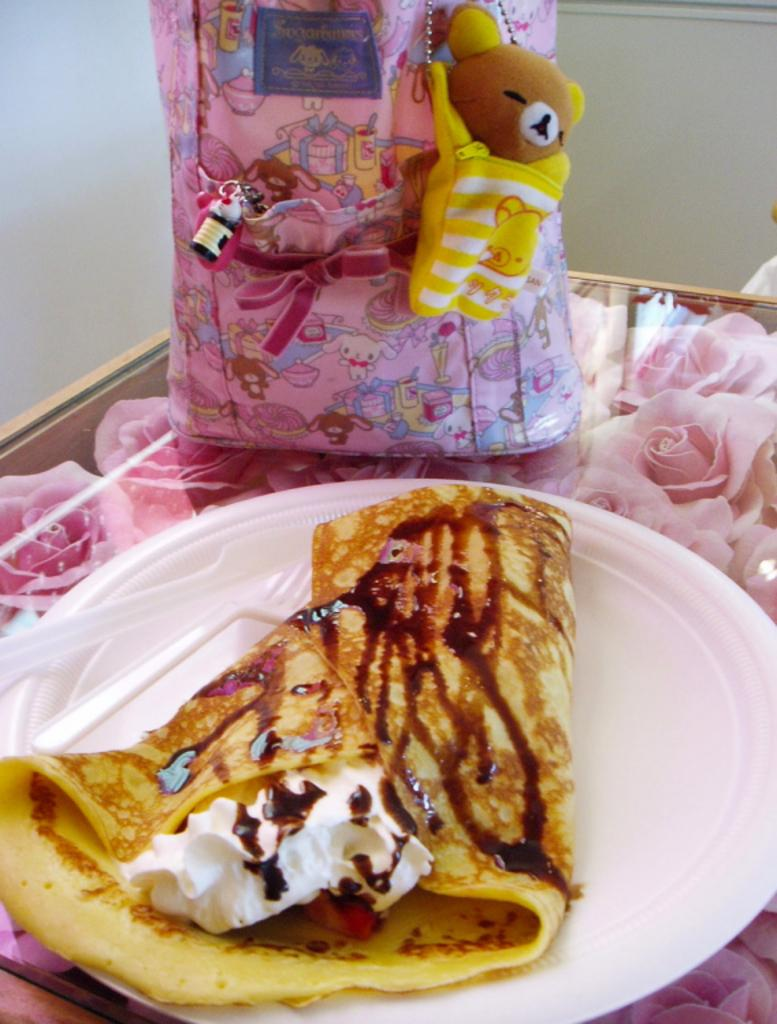What is the main subject of the image? There is a food item in the image. How is the food item presented? The food item is on a plate. What utensils are provided with the food item? A fork and a knife are present with the food item. Where is the plate located? The plate is on a table. What else can be seen beside the plate? There is a bag beside the plate. What is visible behind the bag? There is a wall behind the bag. What type of flesh can be seen hanging from the wall in the image? There is no flesh or any indication of it hanging from the wall in the image. 